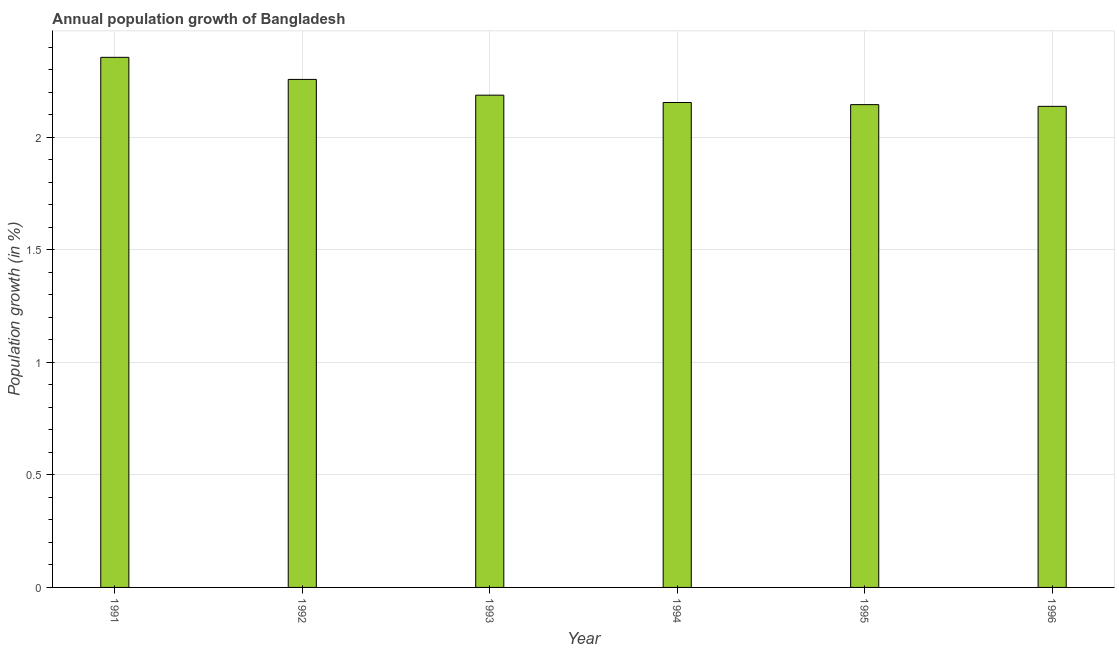What is the title of the graph?
Provide a short and direct response. Annual population growth of Bangladesh. What is the label or title of the X-axis?
Your answer should be compact. Year. What is the label or title of the Y-axis?
Give a very brief answer. Population growth (in %). What is the population growth in 1994?
Make the answer very short. 2.16. Across all years, what is the maximum population growth?
Offer a very short reply. 2.36. Across all years, what is the minimum population growth?
Keep it short and to the point. 2.14. What is the sum of the population growth?
Offer a terse response. 13.24. What is the difference between the population growth in 1994 and 1995?
Make the answer very short. 0.01. What is the average population growth per year?
Keep it short and to the point. 2.21. What is the median population growth?
Give a very brief answer. 2.17. Do a majority of the years between 1993 and 1994 (inclusive) have population growth greater than 1.9 %?
Make the answer very short. Yes. What is the ratio of the population growth in 1991 to that in 1993?
Give a very brief answer. 1.08. What is the difference between the highest and the second highest population growth?
Your answer should be compact. 0.1. Is the sum of the population growth in 1993 and 1996 greater than the maximum population growth across all years?
Your response must be concise. Yes. What is the difference between the highest and the lowest population growth?
Offer a terse response. 0.22. In how many years, is the population growth greater than the average population growth taken over all years?
Your response must be concise. 2. How many bars are there?
Make the answer very short. 6. What is the difference between two consecutive major ticks on the Y-axis?
Your response must be concise. 0.5. What is the Population growth (in %) in 1991?
Your response must be concise. 2.36. What is the Population growth (in %) of 1992?
Your answer should be very brief. 2.26. What is the Population growth (in %) in 1993?
Keep it short and to the point. 2.19. What is the Population growth (in %) in 1994?
Your answer should be very brief. 2.16. What is the Population growth (in %) in 1995?
Provide a succinct answer. 2.15. What is the Population growth (in %) of 1996?
Make the answer very short. 2.14. What is the difference between the Population growth (in %) in 1991 and 1992?
Provide a succinct answer. 0.1. What is the difference between the Population growth (in %) in 1991 and 1993?
Your answer should be compact. 0.17. What is the difference between the Population growth (in %) in 1991 and 1994?
Offer a very short reply. 0.2. What is the difference between the Population growth (in %) in 1991 and 1995?
Give a very brief answer. 0.21. What is the difference between the Population growth (in %) in 1991 and 1996?
Keep it short and to the point. 0.22. What is the difference between the Population growth (in %) in 1992 and 1993?
Your response must be concise. 0.07. What is the difference between the Population growth (in %) in 1992 and 1994?
Offer a terse response. 0.1. What is the difference between the Population growth (in %) in 1992 and 1995?
Ensure brevity in your answer.  0.11. What is the difference between the Population growth (in %) in 1992 and 1996?
Offer a terse response. 0.12. What is the difference between the Population growth (in %) in 1993 and 1994?
Offer a terse response. 0.03. What is the difference between the Population growth (in %) in 1993 and 1995?
Your response must be concise. 0.04. What is the difference between the Population growth (in %) in 1993 and 1996?
Keep it short and to the point. 0.05. What is the difference between the Population growth (in %) in 1994 and 1995?
Your response must be concise. 0.01. What is the difference between the Population growth (in %) in 1994 and 1996?
Your response must be concise. 0.02. What is the difference between the Population growth (in %) in 1995 and 1996?
Keep it short and to the point. 0.01. What is the ratio of the Population growth (in %) in 1991 to that in 1992?
Keep it short and to the point. 1.04. What is the ratio of the Population growth (in %) in 1991 to that in 1993?
Offer a very short reply. 1.08. What is the ratio of the Population growth (in %) in 1991 to that in 1994?
Make the answer very short. 1.09. What is the ratio of the Population growth (in %) in 1991 to that in 1995?
Provide a succinct answer. 1.1. What is the ratio of the Population growth (in %) in 1991 to that in 1996?
Give a very brief answer. 1.1. What is the ratio of the Population growth (in %) in 1992 to that in 1993?
Offer a terse response. 1.03. What is the ratio of the Population growth (in %) in 1992 to that in 1994?
Keep it short and to the point. 1.05. What is the ratio of the Population growth (in %) in 1992 to that in 1995?
Offer a very short reply. 1.05. What is the ratio of the Population growth (in %) in 1992 to that in 1996?
Keep it short and to the point. 1.06. What is the ratio of the Population growth (in %) in 1993 to that in 1994?
Your answer should be very brief. 1.01. What is the ratio of the Population growth (in %) in 1993 to that in 1996?
Provide a short and direct response. 1.02. What is the ratio of the Population growth (in %) in 1994 to that in 1995?
Provide a succinct answer. 1. What is the ratio of the Population growth (in %) in 1995 to that in 1996?
Offer a terse response. 1. 